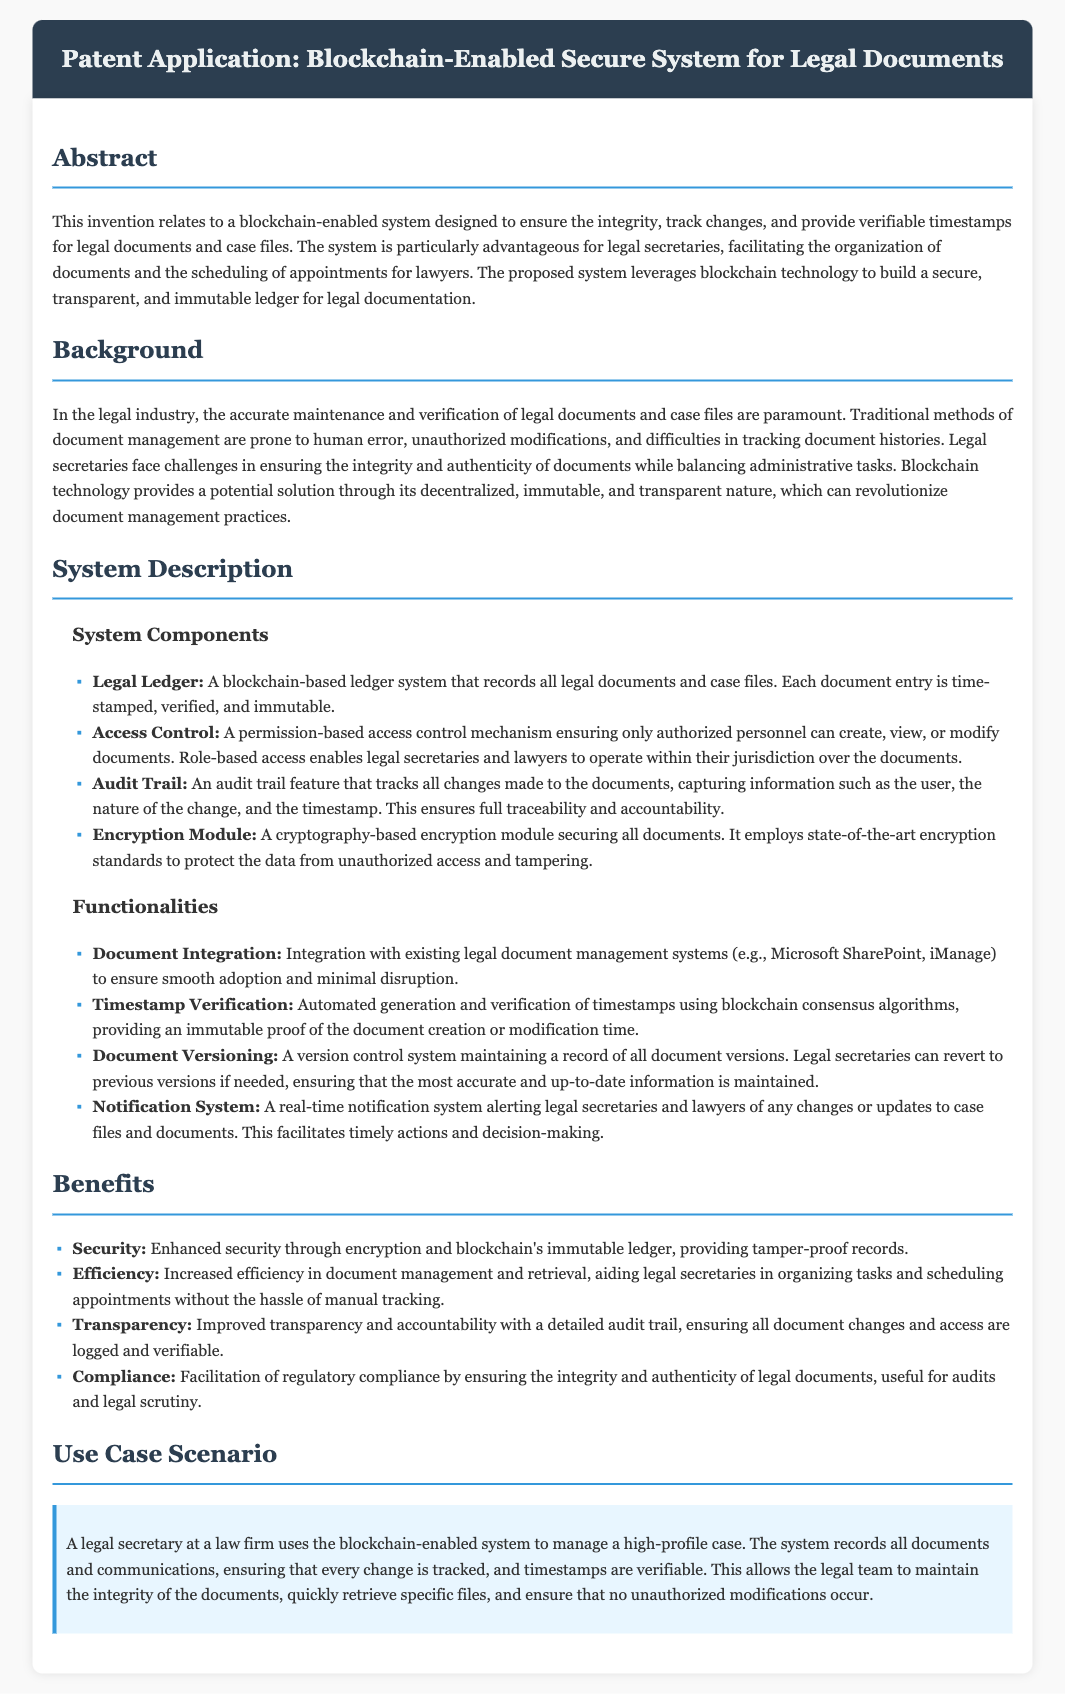What is the main subject of the patent application? The main subject is the implementation of a blockchain-enabled system for legal documents.
Answer: Blockchain-enabled system What does the Legal Ledger do? The Legal Ledger records all legal documents and case files with time stamps, verifications, and immutability.
Answer: Records legal documents What is a key functionality of the system? A key functionality includes automated generation and verification of timestamps.
Answer: Timestamp verification How does the system enhance security? The system enhances security through encryption and the immutable nature of blockchain.
Answer: Encryption and immutability What benefit does the system provide for legal secretaries? The system increases efficiency in document management and retrieval.
Answer: Increased efficiency 